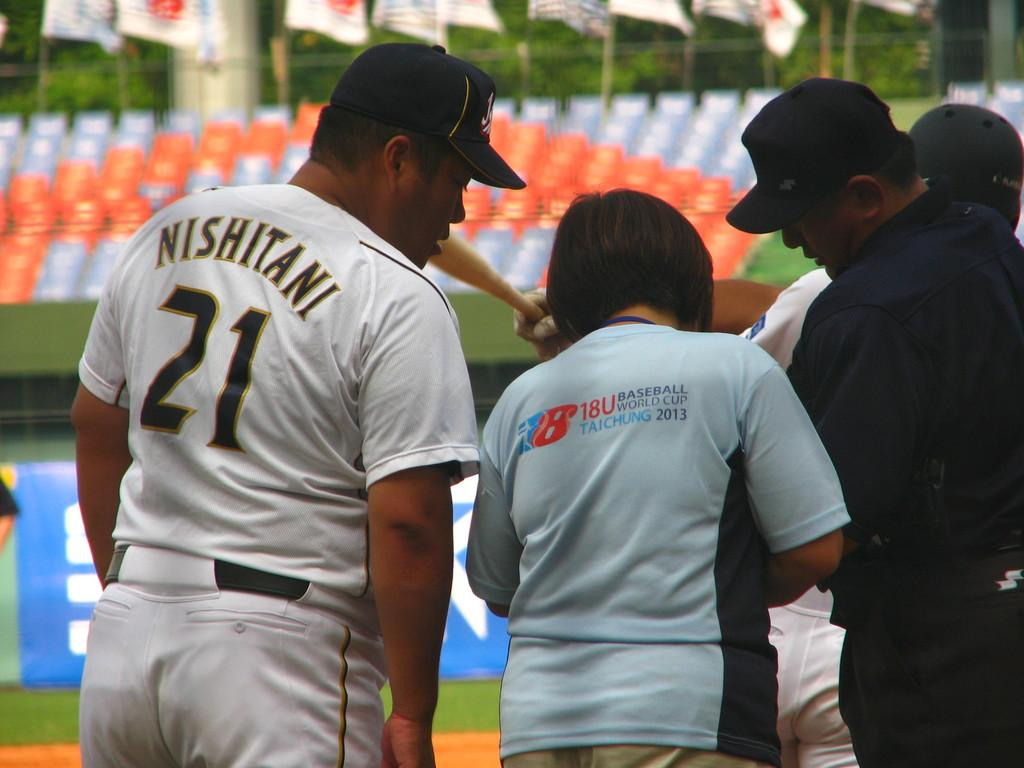<image>
Describe the image concisely. Nishitani wears number 21 and he is looking over someone's shoulder. 